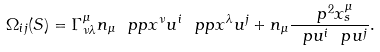Convert formula to latex. <formula><loc_0><loc_0><loc_500><loc_500>\Omega _ { i j } ( S ) = \Gamma ^ { \mu } _ { \nu \lambda } n _ { \mu } \ p p { x ^ { \nu } } { u ^ { i } } \ p p { x ^ { \lambda } } { u ^ { j } } + n _ { \mu } \frac { \ p ^ { 2 } x ^ { \mu } _ { s } } { \ p u ^ { i } \ p u ^ { j } } .</formula> 